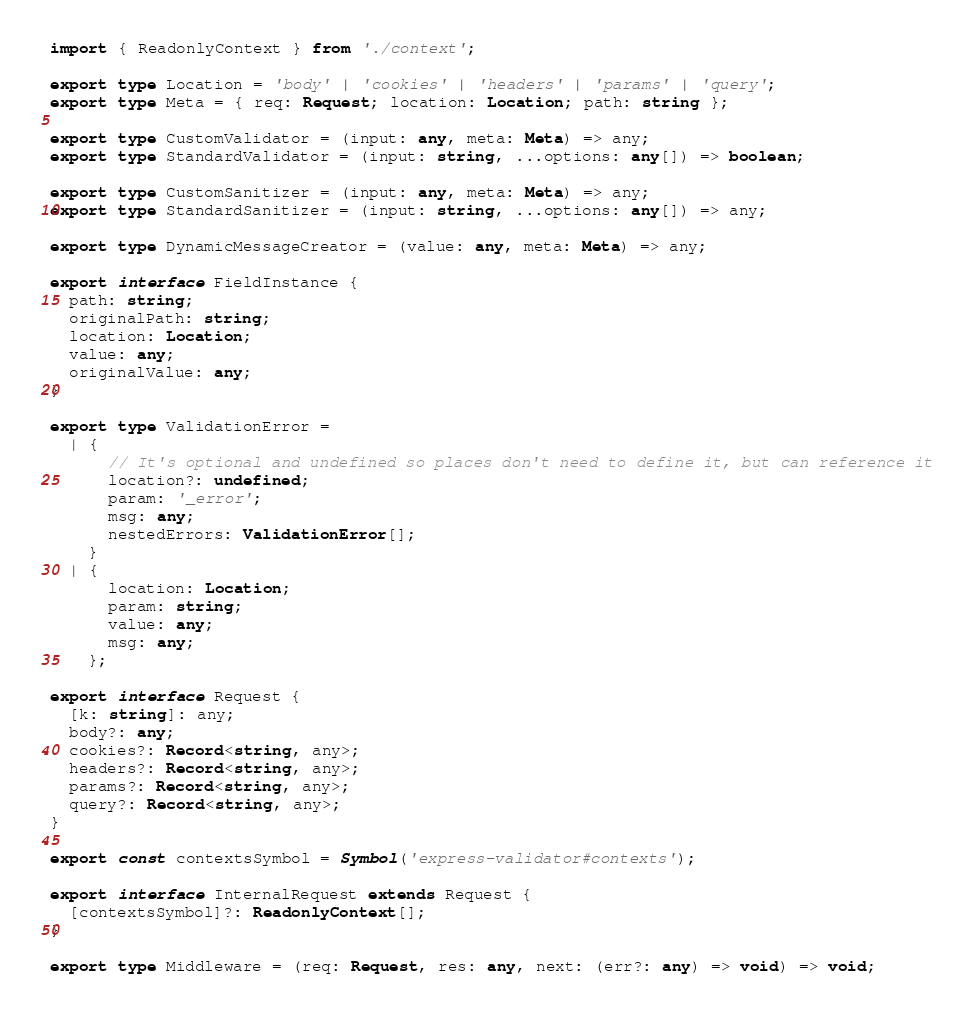<code> <loc_0><loc_0><loc_500><loc_500><_TypeScript_>import { ReadonlyContext } from './context';

export type Location = 'body' | 'cookies' | 'headers' | 'params' | 'query';
export type Meta = { req: Request; location: Location; path: string };

export type CustomValidator = (input: any, meta: Meta) => any;
export type StandardValidator = (input: string, ...options: any[]) => boolean;

export type CustomSanitizer = (input: any, meta: Meta) => any;
export type StandardSanitizer = (input: string, ...options: any[]) => any;

export type DynamicMessageCreator = (value: any, meta: Meta) => any;

export interface FieldInstance {
  path: string;
  originalPath: string;
  location: Location;
  value: any;
  originalValue: any;
}

export type ValidationError =
  | {
      // It's optional and undefined so places don't need to define it, but can reference it
      location?: undefined;
      param: '_error';
      msg: any;
      nestedErrors: ValidationError[];
    }
  | {
      location: Location;
      param: string;
      value: any;
      msg: any;
    };

export interface Request {
  [k: string]: any;
  body?: any;
  cookies?: Record<string, any>;
  headers?: Record<string, any>;
  params?: Record<string, any>;
  query?: Record<string, any>;
}

export const contextsSymbol = Symbol('express-validator#contexts');

export interface InternalRequest extends Request {
  [contextsSymbol]?: ReadonlyContext[];
}

export type Middleware = (req: Request, res: any, next: (err?: any) => void) => void;
</code> 